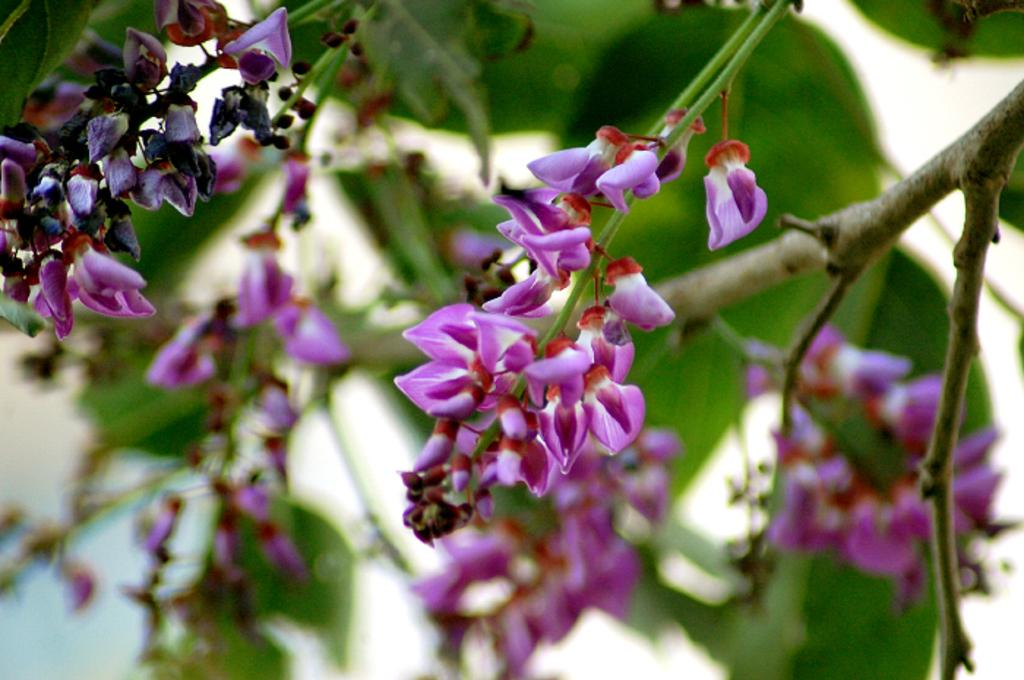What is present in the image? There is a tree in the image. What can be observed about the tree's flowers? The tree has violet color flowers. What is the tendency of the alarm to go off when the tree's flowers are in bloom? There is no alarm present in the image, so it is not possible to determine its tendency when the tree's flowers are in bloom. 